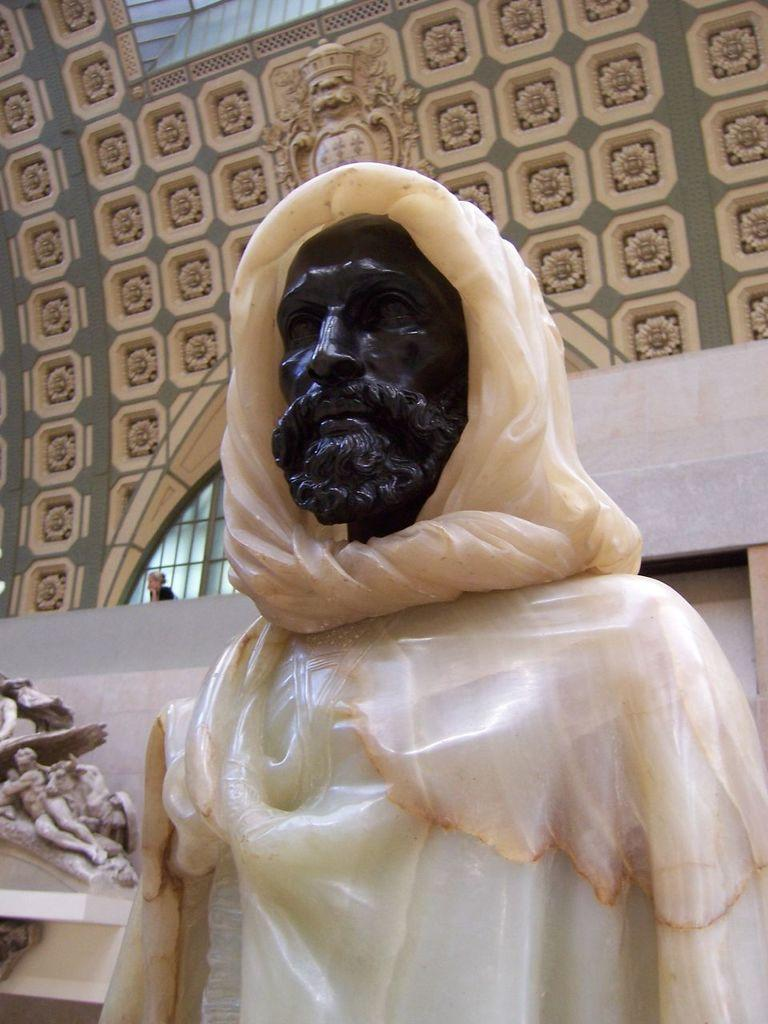What is the main subject in the image? There is a statue in the image. Where is the sculpture located in the image? The sculpture is on the left side of the image. What can be seen in the background of the image? There are wall designs in the background of the image. How does the statue maintain its balance in the image? The statue does not need to maintain its balance, as it is a stationary object in the image. 